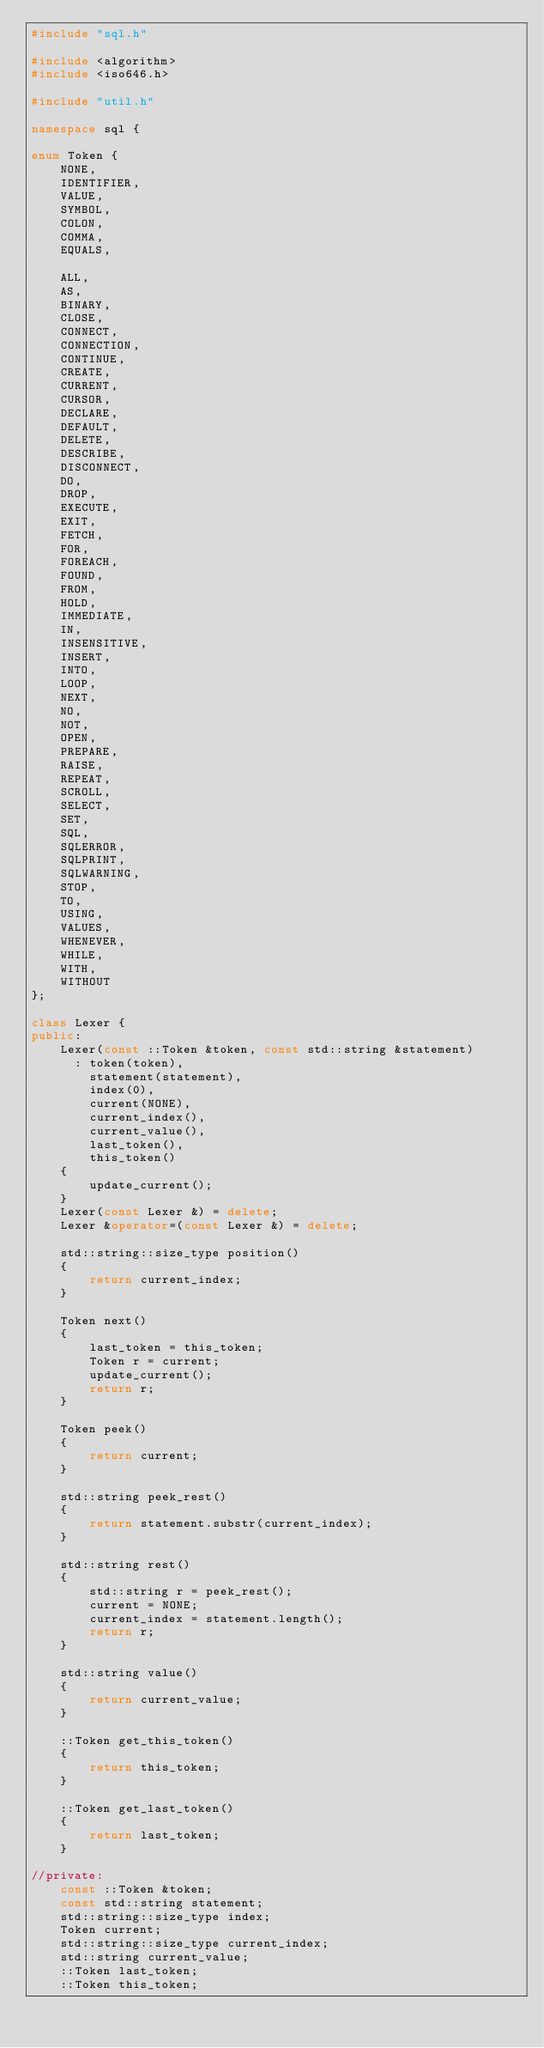<code> <loc_0><loc_0><loc_500><loc_500><_C++_>#include "sql.h"

#include <algorithm>
#include <iso646.h>

#include "util.h"

namespace sql {

enum Token {
    NONE,
    IDENTIFIER,
    VALUE,
    SYMBOL,
    COLON,
    COMMA,
    EQUALS,

    ALL,
    AS,
    BINARY,
    CLOSE,
    CONNECT,
    CONNECTION,
    CONTINUE,
    CREATE,
    CURRENT,
    CURSOR,
    DECLARE,
    DEFAULT,
    DELETE,
    DESCRIBE,
    DISCONNECT,
    DO,
    DROP,
    EXECUTE,
    EXIT,
    FETCH,
    FOR,
    FOREACH,
    FOUND,
    FROM,
    HOLD,
    IMMEDIATE,
    IN,
    INSENSITIVE,
    INSERT,
    INTO,
    LOOP,
    NEXT,
    NO,
    NOT,
    OPEN,
    PREPARE,
    RAISE,
    REPEAT,
    SCROLL,
    SELECT,
    SET,
    SQL,
    SQLERROR,
    SQLPRINT,
    SQLWARNING,
    STOP,
    TO,
    USING,
    VALUES,
    WHENEVER,
    WHILE,
    WITH,
    WITHOUT
};

class Lexer {
public:
    Lexer(const ::Token &token, const std::string &statement)
      : token(token),
        statement(statement),
        index(0),
        current(NONE),
        current_index(),
        current_value(),
        last_token(),
        this_token()
    {
        update_current();
    }
    Lexer(const Lexer &) = delete;
    Lexer &operator=(const Lexer &) = delete;

    std::string::size_type position()
    {
        return current_index;
    }

    Token next()
    {
        last_token = this_token;
        Token r = current;
        update_current();
        return r;
    }

    Token peek()
    {
        return current;
    }

    std::string peek_rest()
    {
        return statement.substr(current_index);
    }

    std::string rest()
    {
        std::string r = peek_rest();
        current = NONE;
        current_index = statement.length();
        return r;
    }

    std::string value()
    {
        return current_value;
    }

    ::Token get_this_token()
    {
        return this_token;
    }

    ::Token get_last_token()
    {
        return last_token;
    }

//private:
    const ::Token &token;
    const std::string statement;
    std::string::size_type index;
    Token current;
    std::string::size_type current_index;
    std::string current_value;
    ::Token last_token;
    ::Token this_token;
</code> 